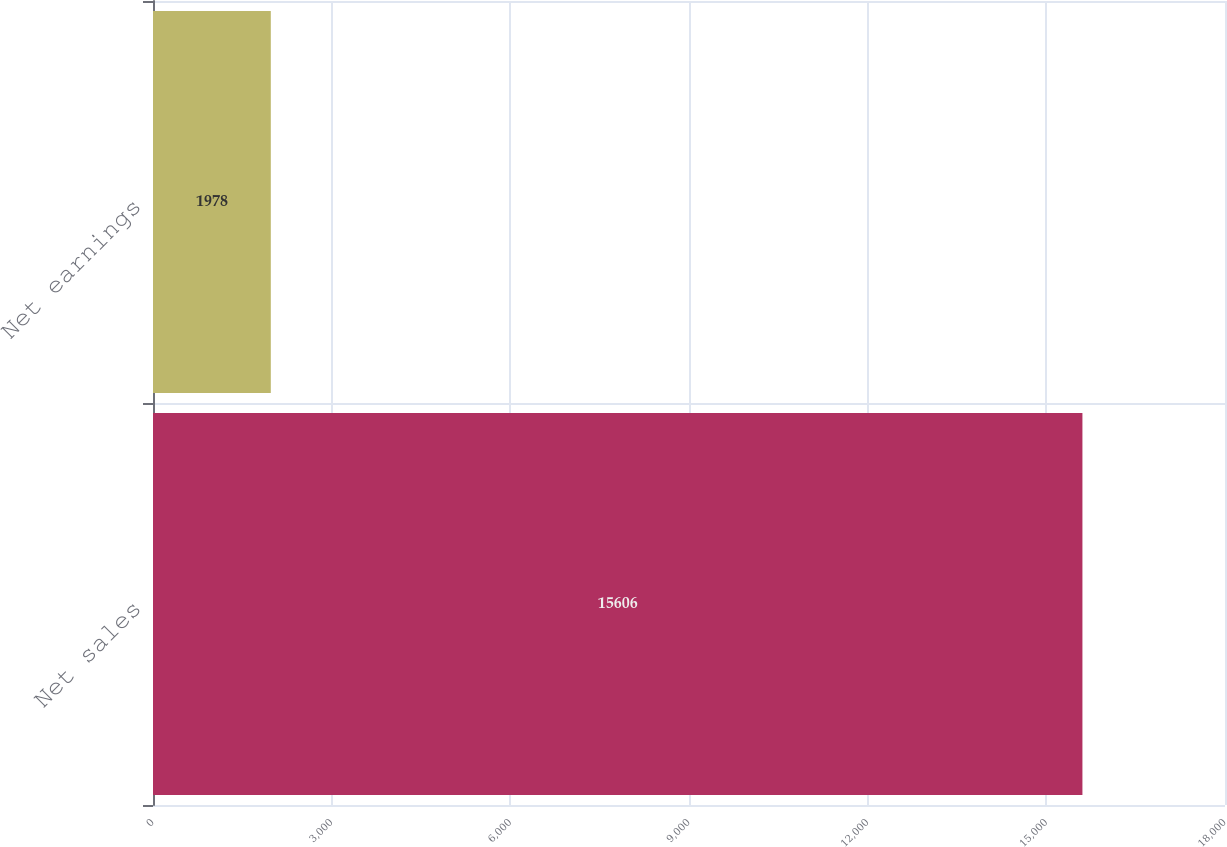Convert chart to OTSL. <chart><loc_0><loc_0><loc_500><loc_500><bar_chart><fcel>Net sales<fcel>Net earnings<nl><fcel>15606<fcel>1978<nl></chart> 